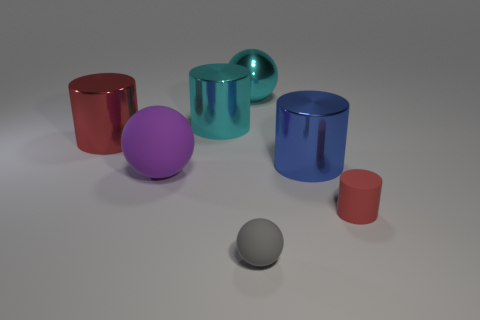Does the big red cylinder have the same material as the big cyan ball?
Your response must be concise. Yes. What number of other things are the same material as the large red thing?
Offer a terse response. 3. Are there more metal cylinders than tiny rubber objects?
Your answer should be very brief. Yes. Is the shape of the big cyan object right of the cyan cylinder the same as  the red rubber thing?
Make the answer very short. No. Is the number of tiny blue metal spheres less than the number of red shiny cylinders?
Offer a very short reply. Yes. There is a blue object that is the same size as the red shiny object; what is its material?
Provide a succinct answer. Metal. Does the matte cylinder have the same color as the big sphere in front of the cyan cylinder?
Make the answer very short. No. Are there fewer big red cylinders to the right of the small red cylinder than large red rubber objects?
Offer a very short reply. No. What number of big blue cylinders are there?
Provide a succinct answer. 1. What is the shape of the red thing to the left of the big purple sphere that is in front of the large red cylinder?
Give a very brief answer. Cylinder. 